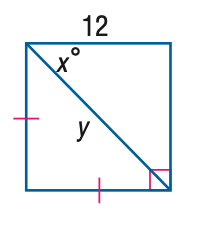Answer the mathemtical geometry problem and directly provide the correct option letter.
Question: Find x.
Choices: A: 30 B: 45 C: 60 D: 90 B 